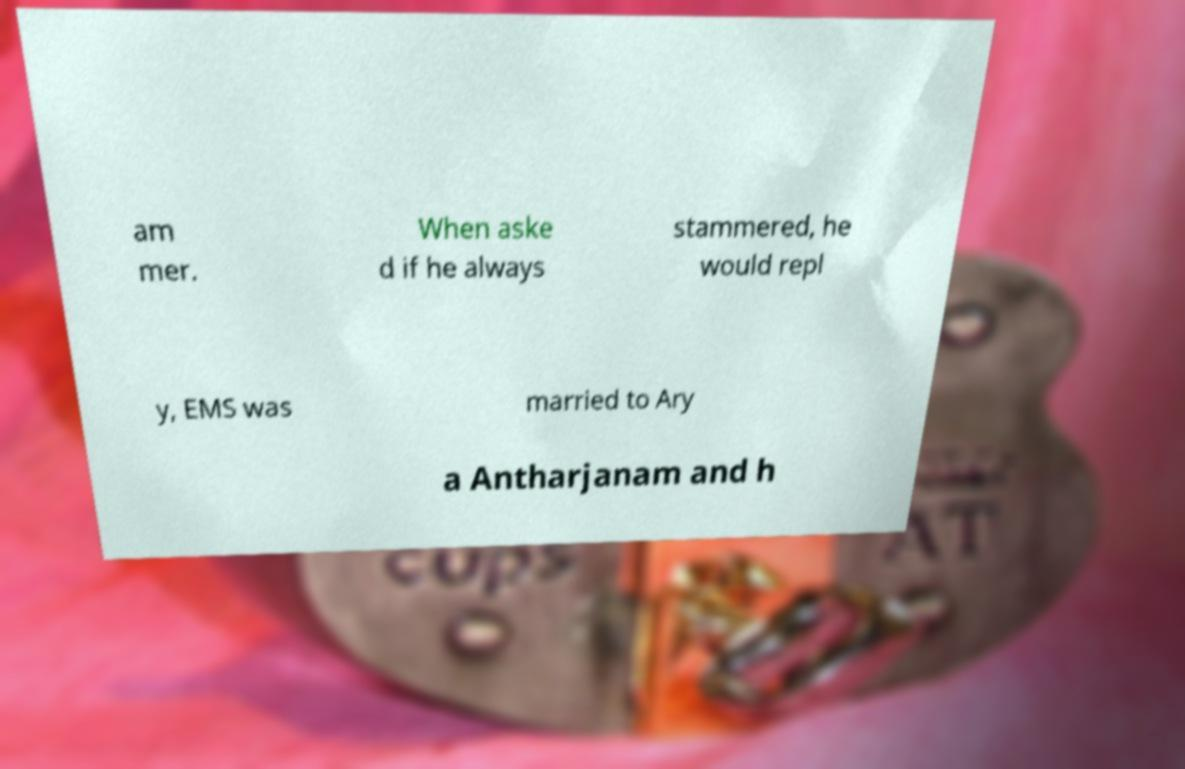For documentation purposes, I need the text within this image transcribed. Could you provide that? am mer. When aske d if he always stammered, he would repl y, EMS was married to Ary a Antharjanam and h 